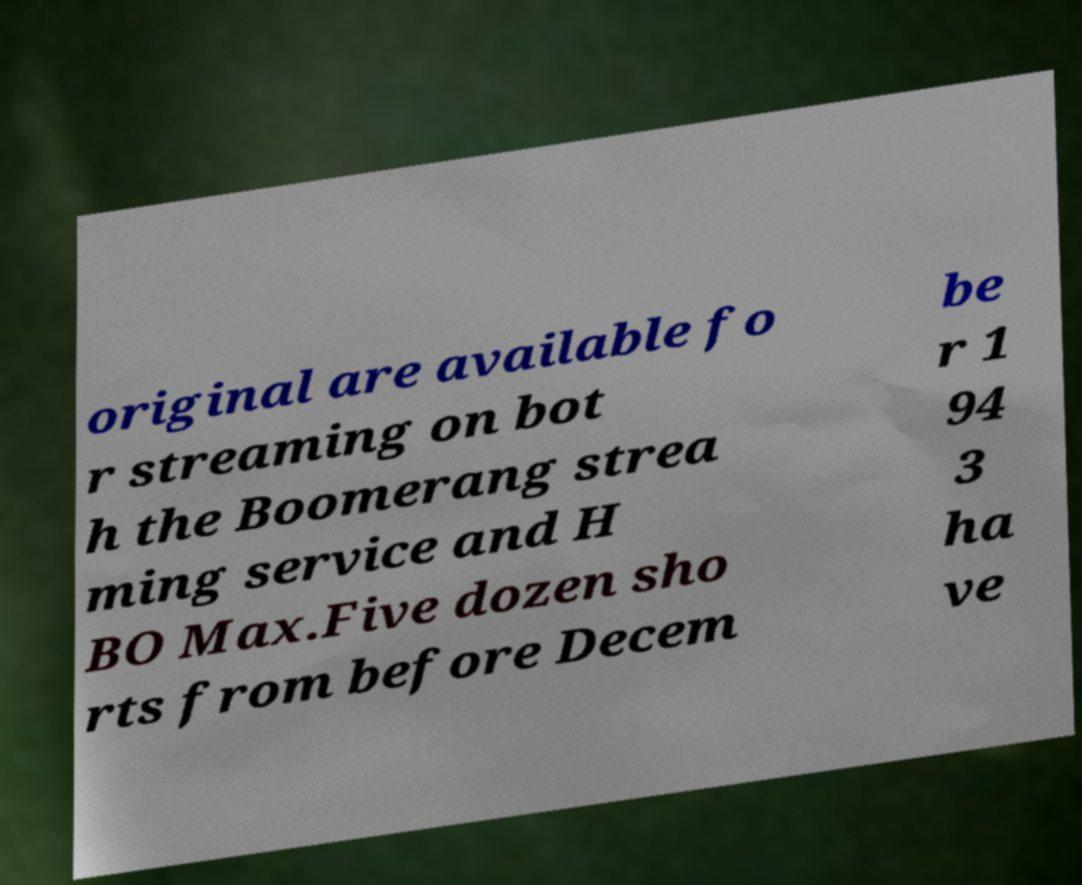Please identify and transcribe the text found in this image. original are available fo r streaming on bot h the Boomerang strea ming service and H BO Max.Five dozen sho rts from before Decem be r 1 94 3 ha ve 